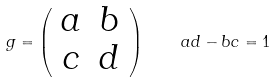Convert formula to latex. <formula><loc_0><loc_0><loc_500><loc_500>g = \left ( \begin{array} { c c } a & b \\ c & d \end{array} \right ) \quad a d - b c = 1</formula> 